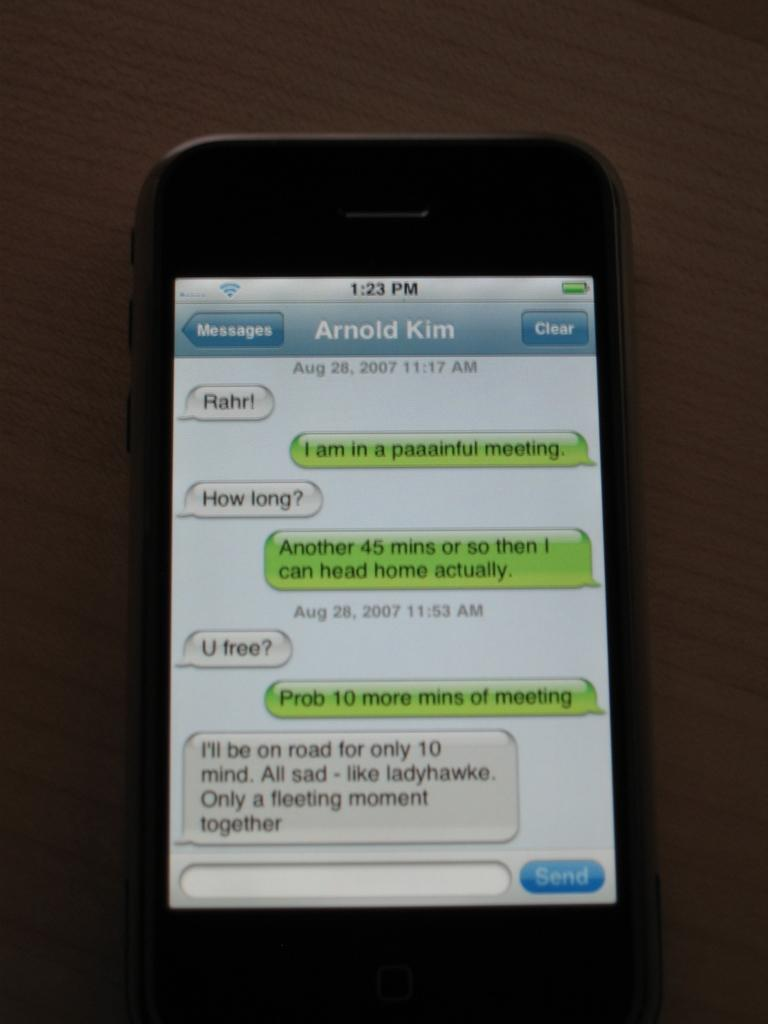<image>
Describe the image concisely. a page from a phone that says Arnold KIm on it 